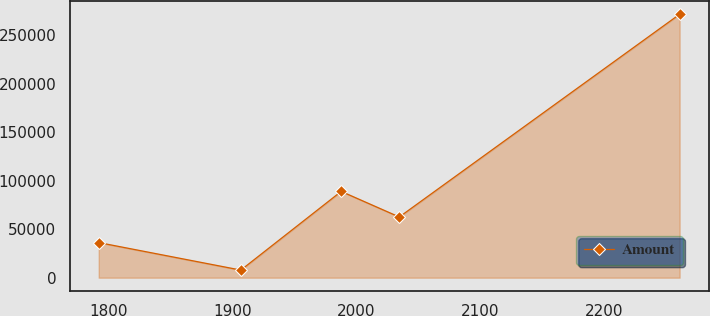Convert chart to OTSL. <chart><loc_0><loc_0><loc_500><loc_500><line_chart><ecel><fcel>Amount<nl><fcel>1792.01<fcel>36199.4<nl><fcel>1906.77<fcel>7840.97<nl><fcel>1987.78<fcel>88914.6<nl><fcel>2034.68<fcel>62557<nl><fcel>2261.02<fcel>271417<nl></chart> 